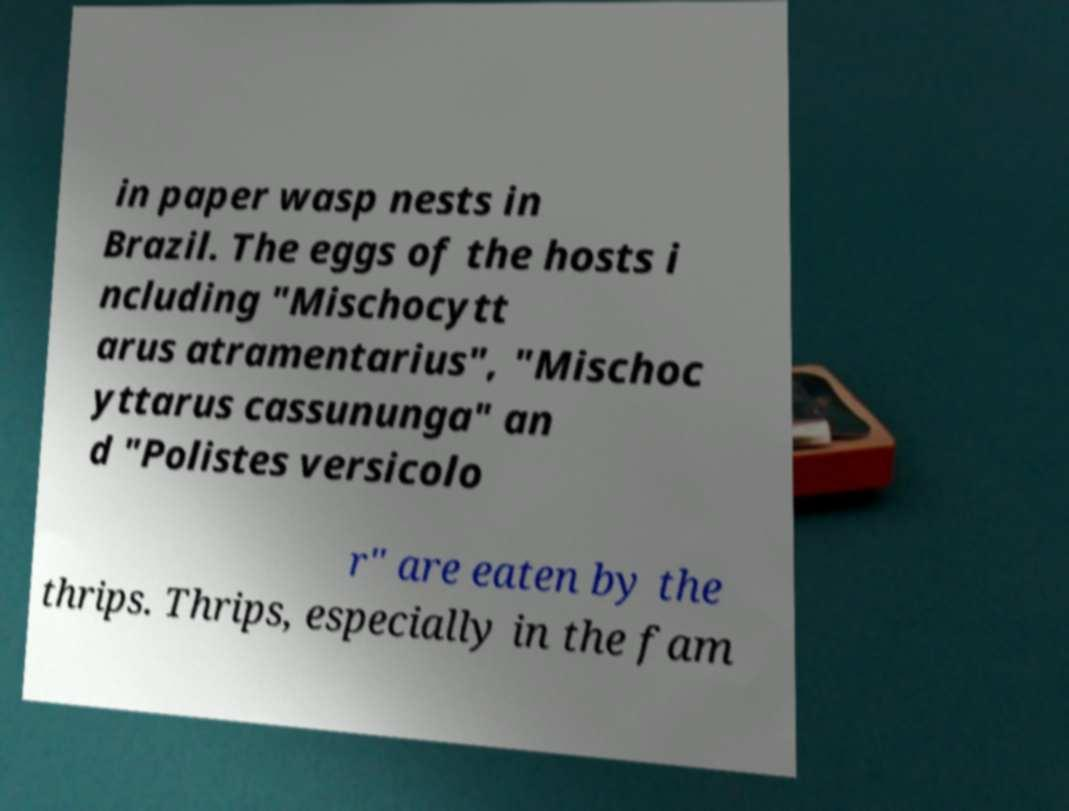Can you accurately transcribe the text from the provided image for me? in paper wasp nests in Brazil. The eggs of the hosts i ncluding "Mischocytt arus atramentarius", "Mischoc yttarus cassununga" an d "Polistes versicolo r" are eaten by the thrips. Thrips, especially in the fam 